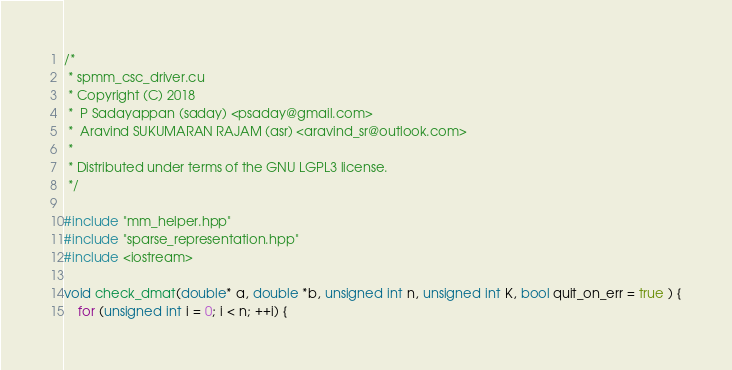Convert code to text. <code><loc_0><loc_0><loc_500><loc_500><_Cuda_>/*
 * spmm_csc_driver.cu
 * Copyright (C) 2018
 *  P Sadayappan (saday) <psaday@gmail.com>
 *  Aravind SUKUMARAN RAJAM (asr) <aravind_sr@outlook.com>
 *
 * Distributed under terms of the GNU LGPL3 license.
 */

#include "mm_helper.hpp"
#include "sparse_representation.hpp"
#include <iostream>

void check_dmat(double* a, double *b, unsigned int n, unsigned int K, bool quit_on_err = true ) {
    for (unsigned int i = 0; i < n; ++i) {</code> 